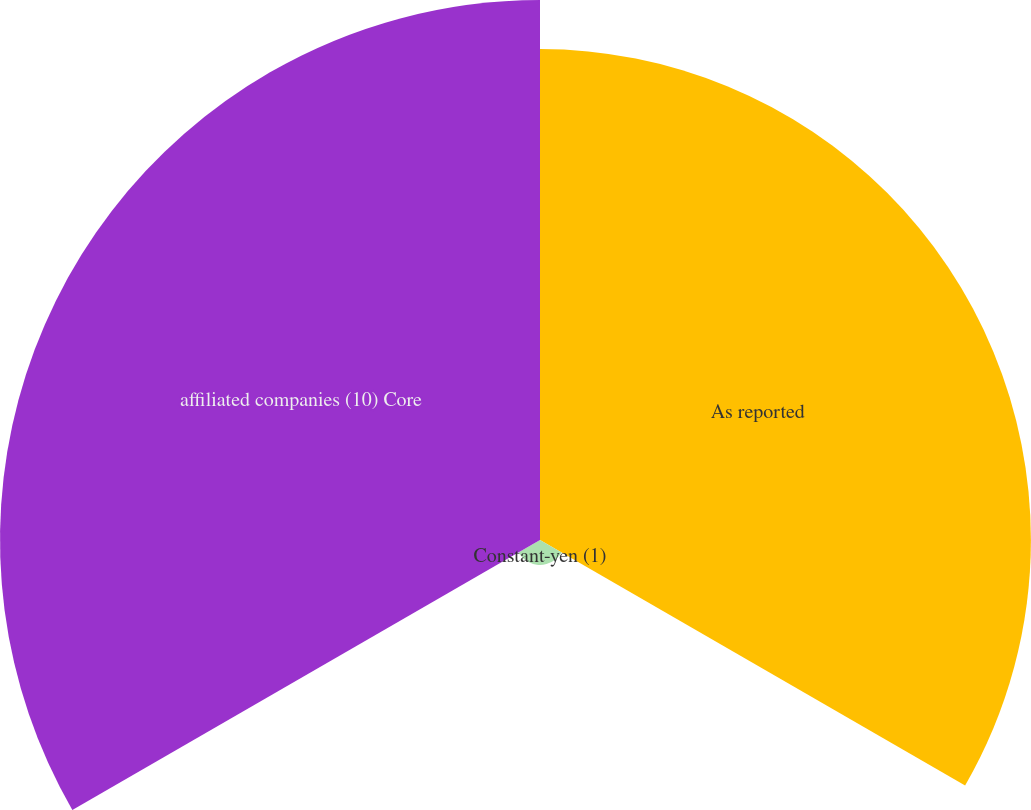Convert chart. <chart><loc_0><loc_0><loc_500><loc_500><pie_chart><fcel>As reported<fcel>Constant-yen (1)<fcel>affiliated companies (10) Core<nl><fcel>46.5%<fcel>2.36%<fcel>51.15%<nl></chart> 